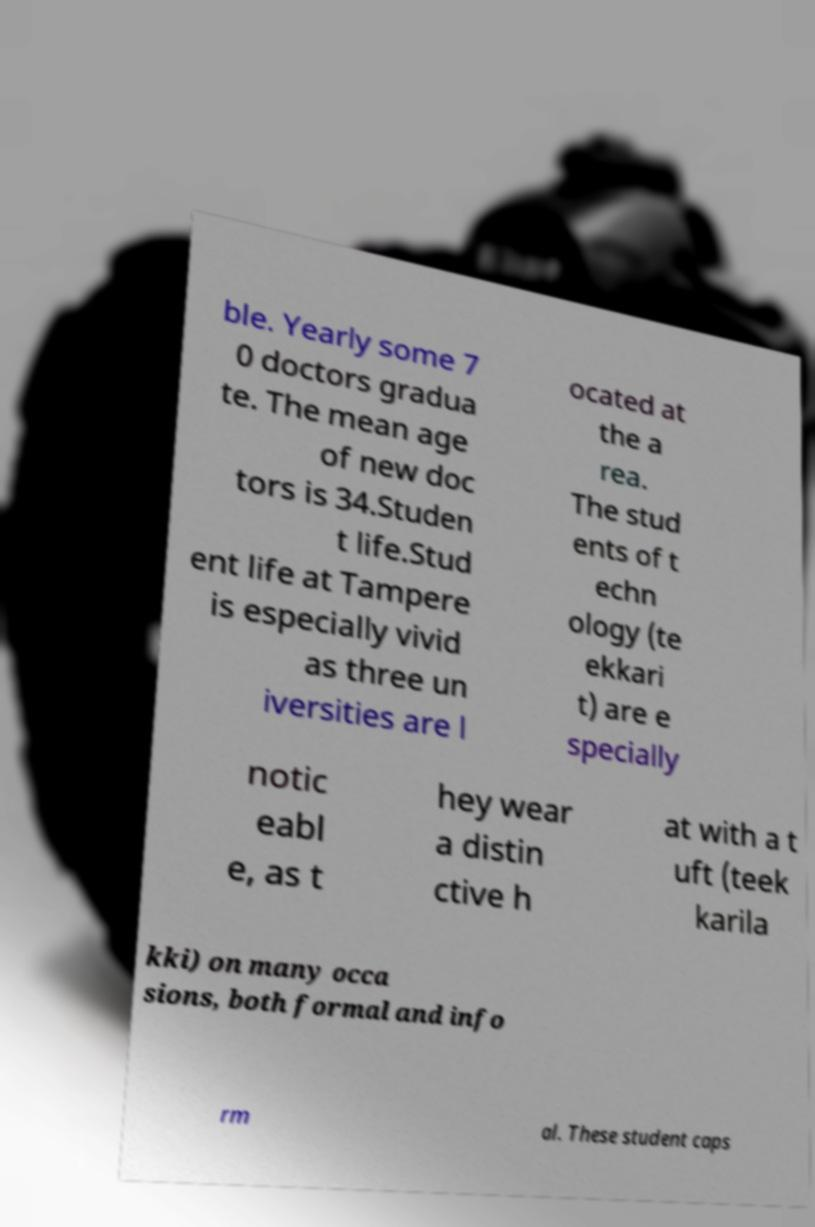Can you accurately transcribe the text from the provided image for me? ble. Yearly some 7 0 doctors gradua te. The mean age of new doc tors is 34.Studen t life.Stud ent life at Tampere is especially vivid as three un iversities are l ocated at the a rea. The stud ents of t echn ology (te ekkari t) are e specially notic eabl e, as t hey wear a distin ctive h at with a t uft (teek karila kki) on many occa sions, both formal and info rm al. These student caps 